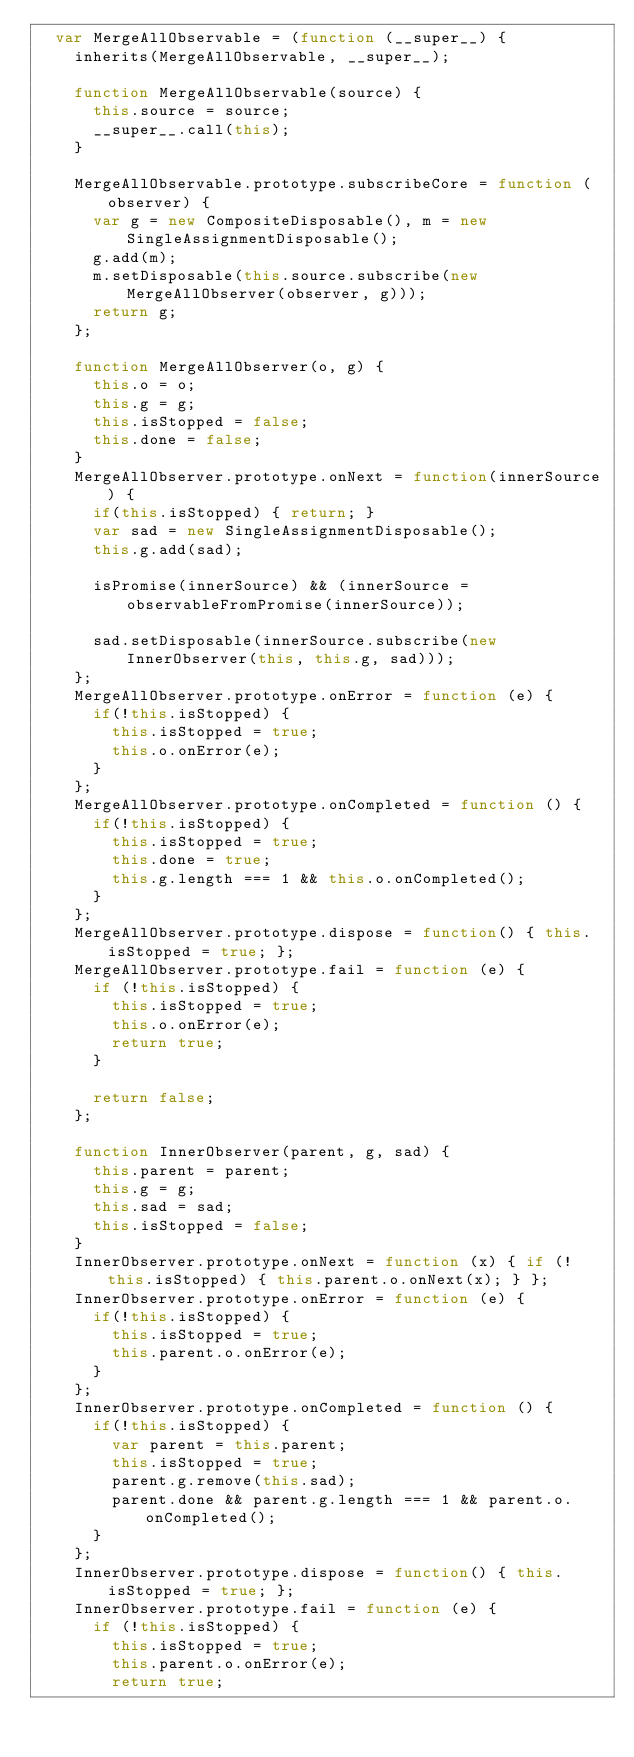Convert code to text. <code><loc_0><loc_0><loc_500><loc_500><_JavaScript_>  var MergeAllObservable = (function (__super__) {
    inherits(MergeAllObservable, __super__);

    function MergeAllObservable(source) {
      this.source = source;
      __super__.call(this);
    }

    MergeAllObservable.prototype.subscribeCore = function (observer) {
      var g = new CompositeDisposable(), m = new SingleAssignmentDisposable();
      g.add(m);
      m.setDisposable(this.source.subscribe(new MergeAllObserver(observer, g)));
      return g;
    };
    
    function MergeAllObserver(o, g) {
      this.o = o;
      this.g = g;
      this.isStopped = false;
      this.done = false;
    }
    MergeAllObserver.prototype.onNext = function(innerSource) {
      if(this.isStopped) { return; }
      var sad = new SingleAssignmentDisposable();
      this.g.add(sad);

      isPromise(innerSource) && (innerSource = observableFromPromise(innerSource));

      sad.setDisposable(innerSource.subscribe(new InnerObserver(this, this.g, sad)));
    };
    MergeAllObserver.prototype.onError = function (e) {
      if(!this.isStopped) {
        this.isStopped = true;
        this.o.onError(e);
      }
    };
    MergeAllObserver.prototype.onCompleted = function () {
      if(!this.isStopped) {
        this.isStopped = true;
        this.done = true;
        this.g.length === 1 && this.o.onCompleted();
      }
    };
    MergeAllObserver.prototype.dispose = function() { this.isStopped = true; };
    MergeAllObserver.prototype.fail = function (e) {
      if (!this.isStopped) {
        this.isStopped = true;
        this.o.onError(e);
        return true;
      }

      return false;
    };

    function InnerObserver(parent, g, sad) {
      this.parent = parent;
      this.g = g;
      this.sad = sad;
      this.isStopped = false;
    }
    InnerObserver.prototype.onNext = function (x) { if (!this.isStopped) { this.parent.o.onNext(x); } };
    InnerObserver.prototype.onError = function (e) {
      if(!this.isStopped) {
        this.isStopped = true;
        this.parent.o.onError(e);
      }
    };
    InnerObserver.prototype.onCompleted = function () {
      if(!this.isStopped) {
        var parent = this.parent;
        this.isStopped = true;
        parent.g.remove(this.sad);
        parent.done && parent.g.length === 1 && parent.o.onCompleted();
      }
    };
    InnerObserver.prototype.dispose = function() { this.isStopped = true; };
    InnerObserver.prototype.fail = function (e) {
      if (!this.isStopped) {
        this.isStopped = true;
        this.parent.o.onError(e);
        return true;</code> 